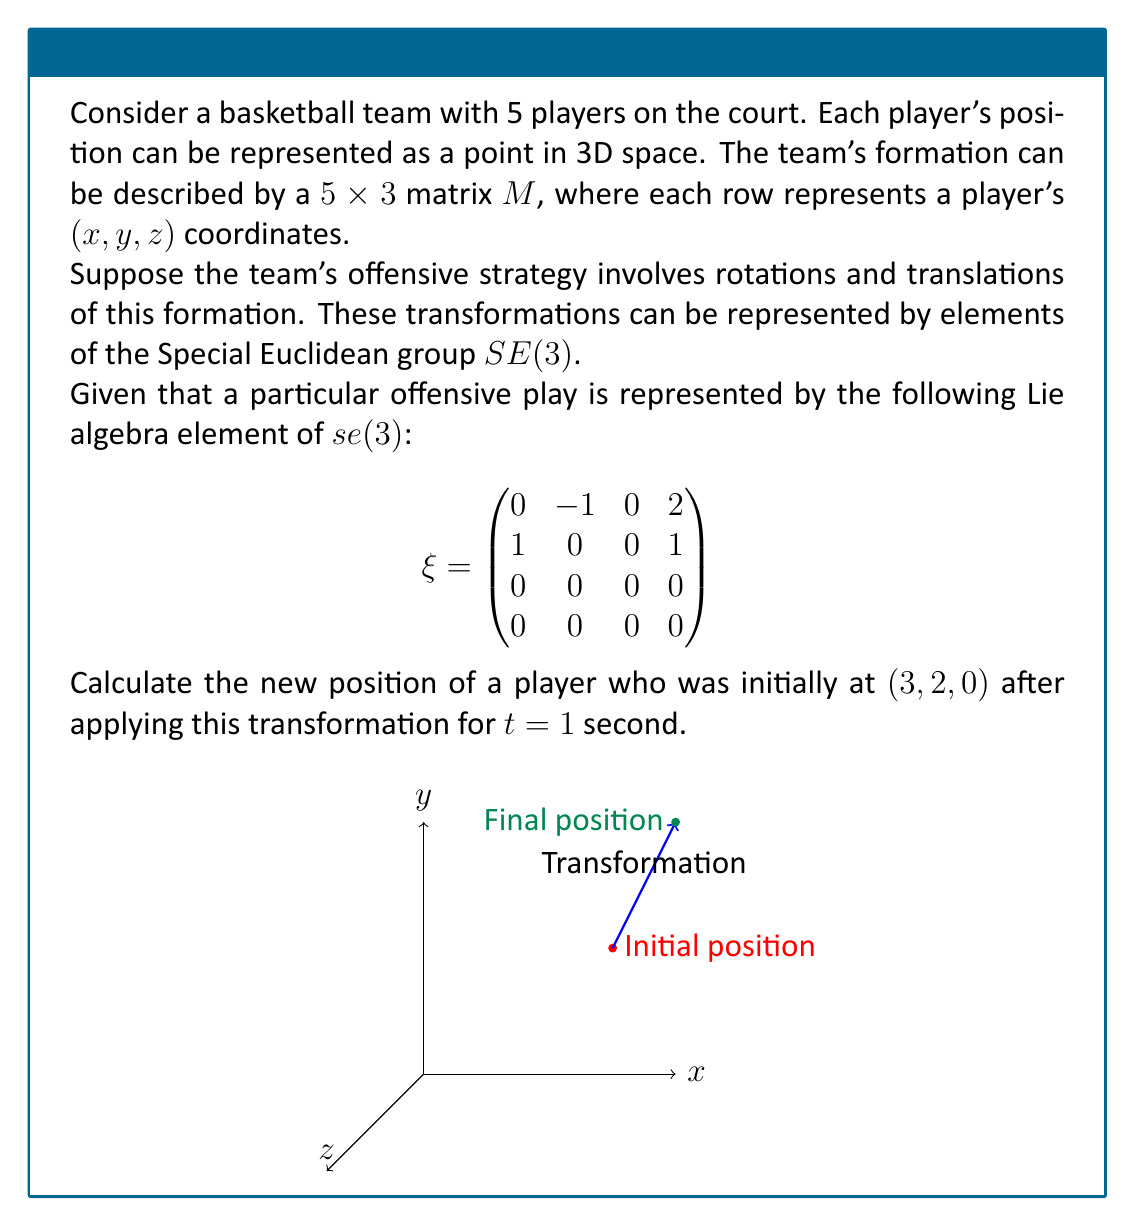Could you help me with this problem? Let's approach this step-by-step:

1) The Lie algebra element $\xi$ represents an infinitesimal transformation. To get the actual transformation, we need to exponentiate it:

   $T = e^{\xi t} = I + \xi t + \frac{(\xi t)^2}{2!} + \frac{(\xi t)^3}{3!} + ...$

2) For $t=1$, we have:

   $T = e^{\xi} = I + \xi + \frac{\xi^2}{2!} + \frac{\xi^3}{3!} + ...$

3) Let's calculate the first few terms:

   $I = \begin{pmatrix}
   1 & 0 & 0 & 0 \\
   0 & 1 & 0 & 0 \\
   0 & 0 & 1 & 0 \\
   0 & 0 & 0 & 1
   \end{pmatrix}$

   $\xi = \begin{pmatrix}
   0 & -1 & 0 & 2 \\
   1 & 0 & 0 & 1 \\
   0 & 0 & 0 & 0 \\
   0 & 0 & 0 & 0
   \end{pmatrix}$

   $\frac{\xi^2}{2} = \frac{1}{2}\begin{pmatrix}
   -1 & 0 & 0 & 1 \\
   0 & -1 & 0 & 2 \\
   0 & 0 & 0 & 0 \\
   0 & 0 & 0 & 0
   \end{pmatrix}$

   $\frac{\xi^3}{6} = \frac{1}{6}\begin{pmatrix}
   0 & 1 & 0 & -2 \\
   -1 & 0 & 0 & -1 \\
   0 & 0 & 0 & 0 \\
   0 & 0 & 0 & 0
   \end{pmatrix}$

4) Adding these up (and continuing the series), we get:

   $T = e^{\xi} = \begin{pmatrix}
   \cos(1) & -\sin(1) & 0 & 2-2\cos(1) \\
   \sin(1) & \cos(1) & 0 & 2\sin(1) \\
   0 & 0 & 1 & 0 \\
   0 & 0 & 0 & 1
   \end{pmatrix}$

5) To transform the player's position, we need to multiply this matrix by the homogeneous coordinates of the initial position:

   $\begin{pmatrix}
   \cos(1) & -\sin(1) & 0 & 2-2\cos(1) \\
   \sin(1) & \cos(1) & 0 & 2\sin(1) \\
   0 & 0 & 1 & 0 \\
   0 & 0 & 0 & 1
   \end{pmatrix} \begin{pmatrix} 3 \\ 2 \\ 0 \\ 1 \end{pmatrix}$

6) Performing this multiplication:

   $\begin{pmatrix}
   3\cos(1) - 2\sin(1) + 2-2\cos(1) \\
   3\sin(1) + 2\cos(1) + 2\sin(1) \\
   0 \\
   1
   \end{pmatrix}$

7) Evaluating (approximately):

   $\begin{pmatrix}
   3.99 \\
   3.95 \\
   0 \\
   1
   \end{pmatrix}$

Therefore, the player's new position is approximately (4.0, 4.0, 0).
Answer: (4.0, 4.0, 0) 